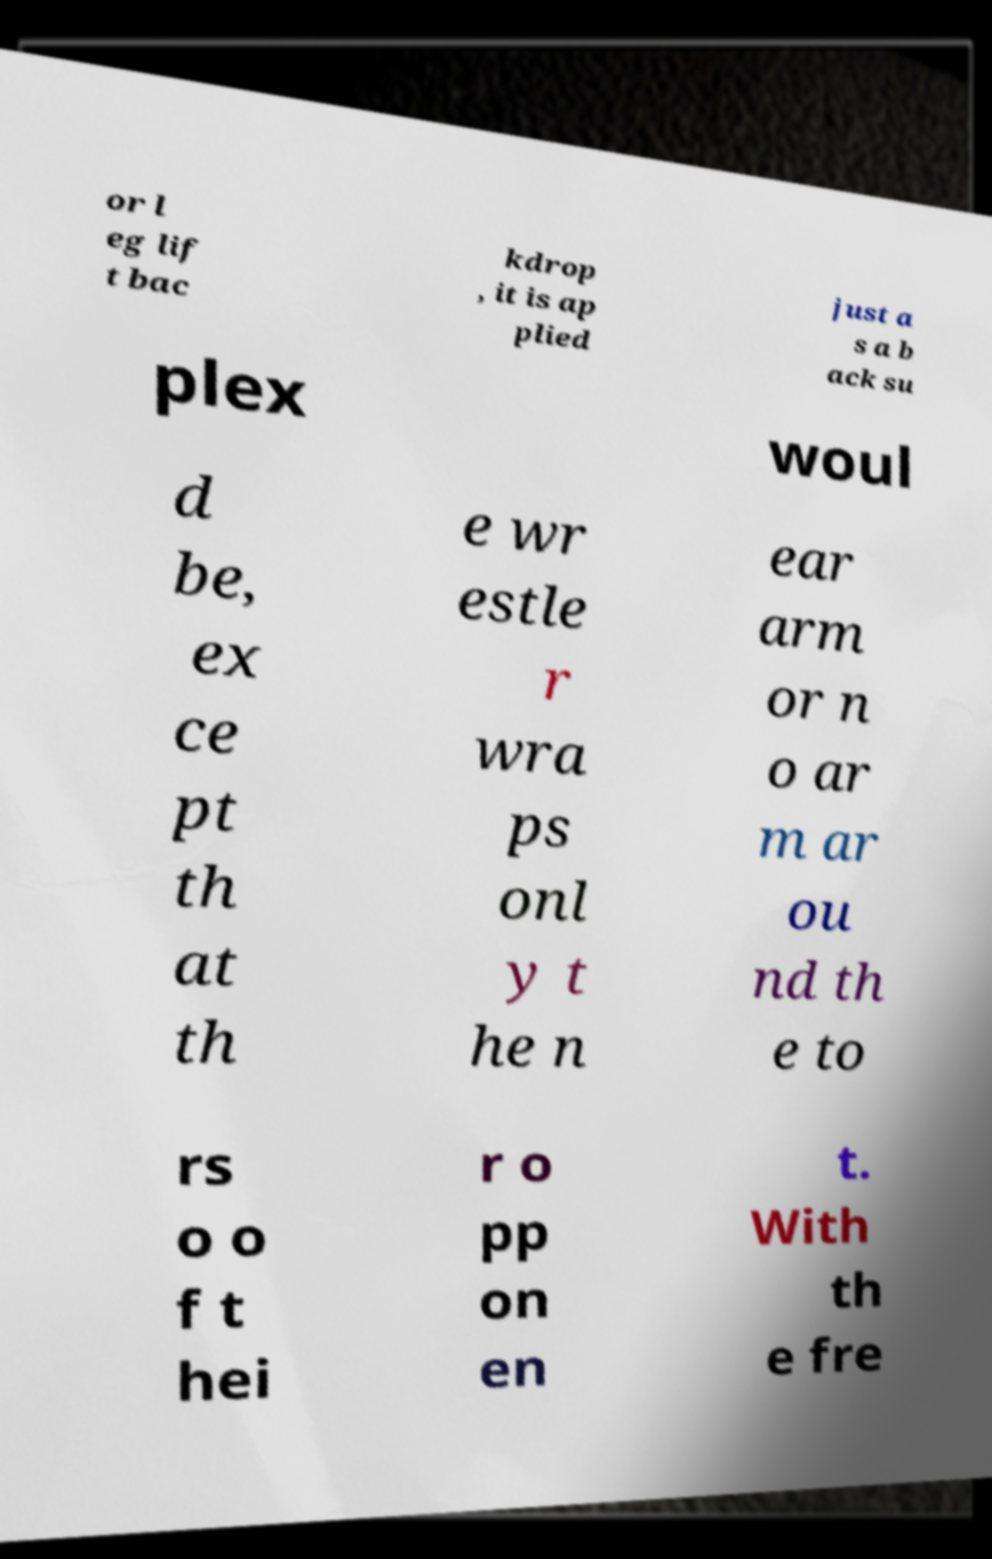I need the written content from this picture converted into text. Can you do that? or l eg lif t bac kdrop , it is ap plied just a s a b ack su plex woul d be, ex ce pt th at th e wr estle r wra ps onl y t he n ear arm or n o ar m ar ou nd th e to rs o o f t hei r o pp on en t. With th e fre 